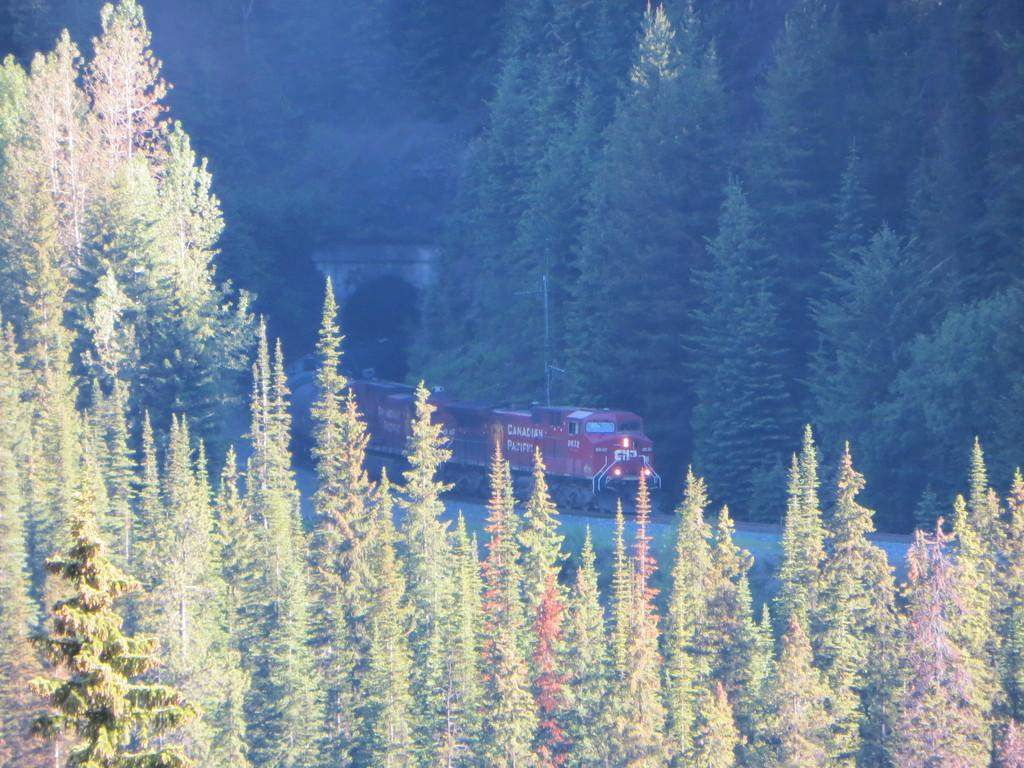What type of vegetation can be seen in the image? There are trees in the image. What mode of transportation is present in the image? There is a train on a railway track in the image. What structure can be seen in the image? There is a tunnel in the image. Where is the crown placed in the image? There is no crown present in the image. What type of crate can be seen in the image? There is no crate present in the image. 